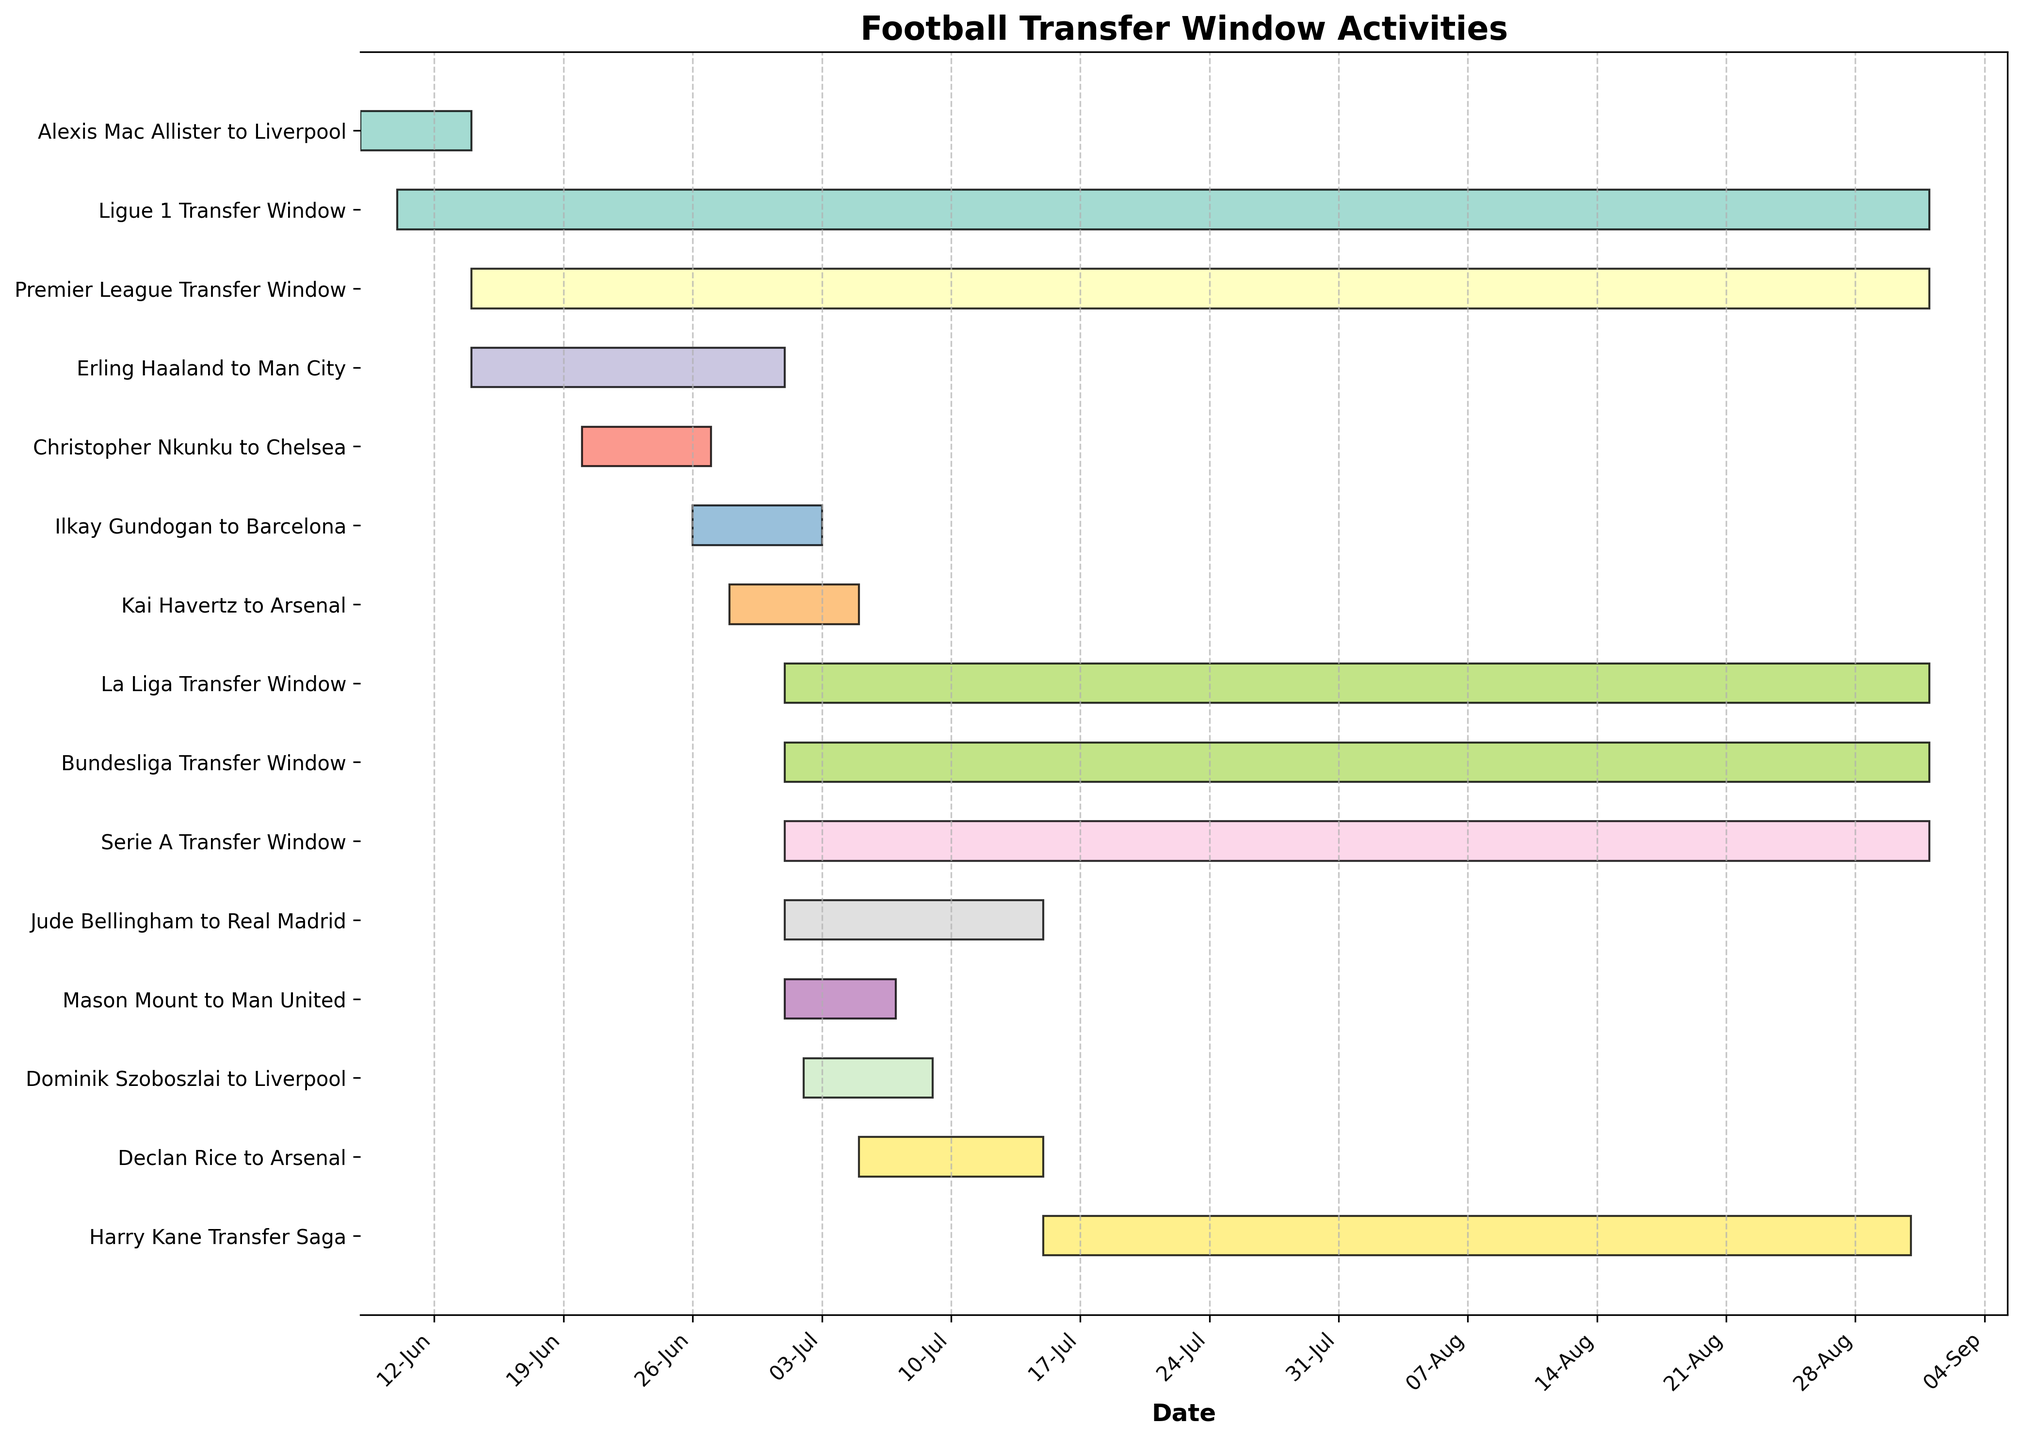What is the title of the Gantt Chart? The title can be found at the top center of the chart.
Answer: Football Transfer Window Activities When does the Premier League Transfer Window start and end? Look at the bar labeled "Premier League Transfer Window" and see its start and end points.
Answer: Starts on June 14, 2023, ends on September 1, 2023 How many transfer windows have the same end date? Observe the bars representing transfer windows and count how many end on the same date.
Answer: Four transfer windows end on September 1, 2023 Which player transfer started last in the timeline? Find the player transfer that started the latest by looking at the beginning of each bar representing player transfers.
Answer: Harry Kane Transfer Saga Which player transfers completed within the shortest duration? Compare the widths of the bars representing player transfers to find the shortest one.
Answer: Christopher Nkunku to Chelsea (June 20, 2023, to June 27, 2023) Which two player transfers started on the same date? Identify bars representing player transfers and compare their start dates to find a match.
Answer: Mason Mount to Man United and Jude Bellingham to Real Madrid (July 1, 2023) How many days did the Erling Haaland to Man City transfer take to complete? Calculate the duration by subtracting the start date from the end date (July 1, 2023 - June 14, 2023).
Answer: 17 days Compare the transfer durations of Declan Rice to Arsenal and Kai Havertz to Arsenal: which took longer? Calculate the durations of each transfer and compare the two. Declan Rice (July 15 - July 5) = 10 days, Kai Havertz (July 5 - June 28) = 7 days.
Answer: Declan Rice to Arsenal took longer What are the start and end dates of the Ligue 1 Transfer Window? Look at the bar labeled "Ligue 1 Transfer Window" and note its start and end points.
Answer: June 10, 2023, to September 1, 2023 How many days were there between the end of the Christopher Nkunku to Chelsea transfer and the start of the Ilkay Gundogan to Barcelona transfer? Find the end date of Nkunku's transfer and the start date of Gundogan's transfer, then calculate the difference. End of Nkunku (June 27, 2023), start of Gundogan (June 26, 2023), so one day.
Answer: 1 day 